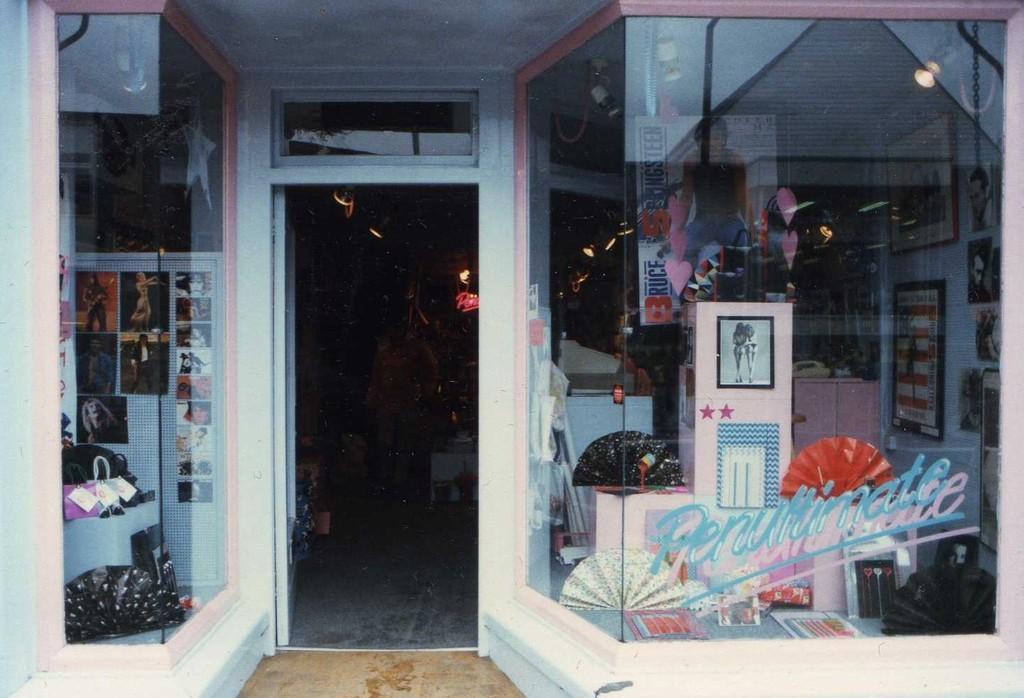Please provide a concise description of this image. This picture shows a store and we see few photographs in the glass box and a couple of photo frames. 